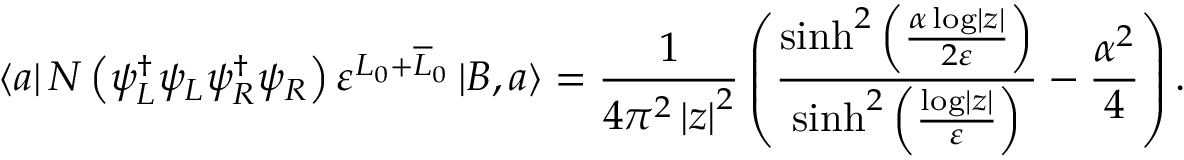<formula> <loc_0><loc_0><loc_500><loc_500>\left \langle a \right | N \left ( \psi _ { L } ^ { \dagger } \psi _ { L } \psi _ { R } ^ { \dagger } \psi _ { R } \right ) \varepsilon ^ { L _ { 0 } + \overline { L } _ { 0 } } \left | B , a \right \rangle = \frac { 1 } { 4 \pi ^ { 2 } \left | z \right | ^ { 2 } } \left ( \frac { \sinh ^ { 2 } \left ( \frac { \alpha \log \left | z \right | } { 2 \varepsilon } \right ) } { \sinh ^ { 2 } \left ( \frac { \log \left | z \right | } { \varepsilon } \right ) } - \frac { \alpha ^ { 2 } } { 4 } \right ) .</formula> 